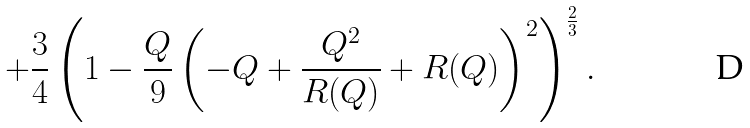Convert formula to latex. <formula><loc_0><loc_0><loc_500><loc_500>+ \frac { 3 } { 4 } \left ( 1 - \frac { Q } { 9 } \left ( - Q + \frac { Q ^ { 2 } } { R ( Q ) } + R ( Q ) \right ) ^ { 2 } \right ) ^ { \frac { 2 } { 3 } } .</formula> 